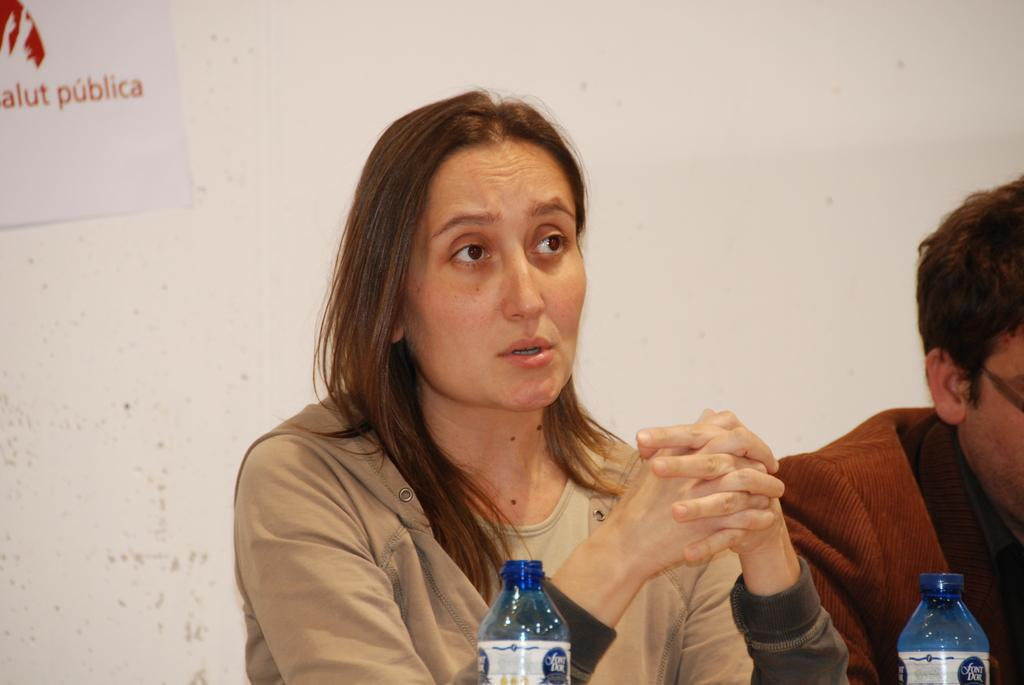Who is present in the image? There is a woman in the image. What objects can be seen in the image? There are bottles in the image. What can be seen in the background of the image? There is a wall in the background of the image. What type of pan is being used to prepare the feast in the image? There is no pan or feast present in the image. 